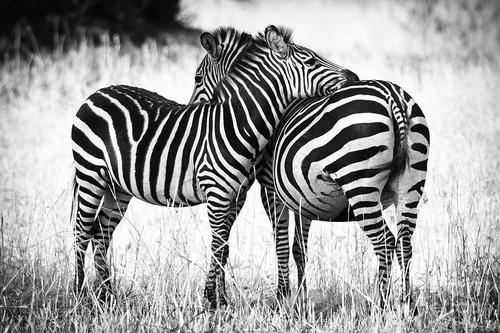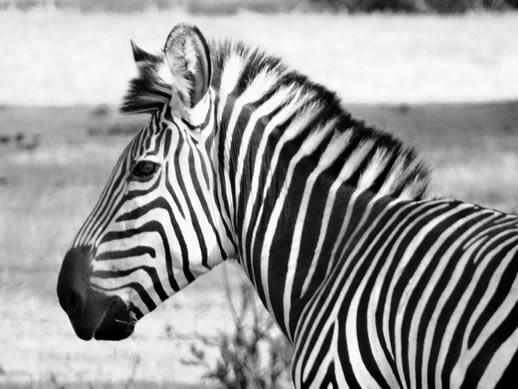The first image is the image on the left, the second image is the image on the right. Evaluate the accuracy of this statement regarding the images: "Two standing zebras whose heads are parallel in height have their bodies turned toward each other in the right image.". Is it true? Answer yes or no. No. The first image is the image on the left, the second image is the image on the right. Evaluate the accuracy of this statement regarding the images: "Both images have the same number of zebras.". Is it true? Answer yes or no. No. 